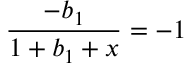Convert formula to latex. <formula><loc_0><loc_0><loc_500><loc_500>{ \frac { - b _ { 1 } } { 1 + b _ { 1 } + x } } = - 1</formula> 